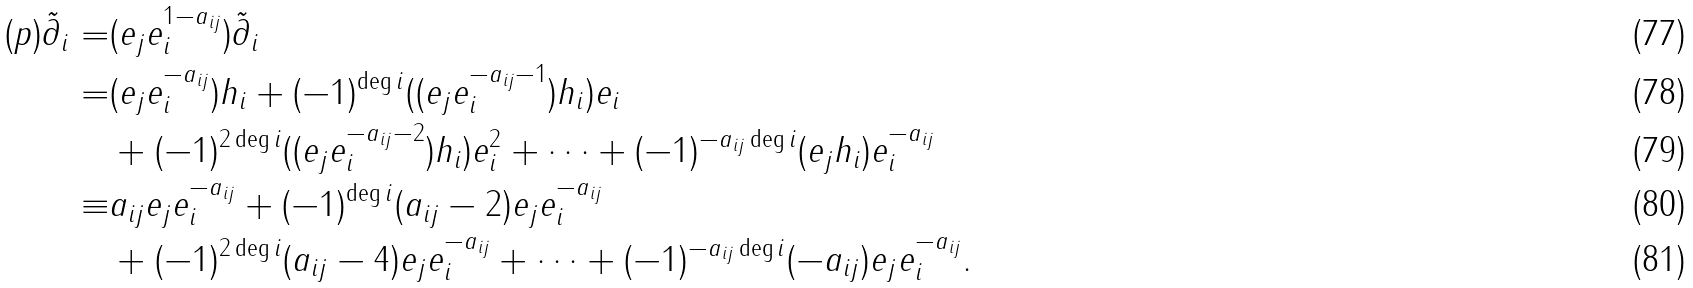<formula> <loc_0><loc_0><loc_500><loc_500>( p ) \tilde { \partial } _ { i } = & ( e _ { j } e _ { i } ^ { 1 - a _ { i j } } ) \tilde { \partial } _ { i } \\ = & ( e _ { j } e _ { i } ^ { - a _ { i j } } ) h _ { i } + ( - 1 ) ^ { \deg i } ( ( e _ { j } e _ { i } ^ { - a _ { i j } - 1 } ) h _ { i } ) e _ { i } \\ & + ( - 1 ) ^ { 2 \deg i } ( ( e _ { j } e _ { i } ^ { - a _ { i j } - 2 } ) h _ { i } ) e _ { i } ^ { 2 } + \dots + ( - 1 ) ^ { - a _ { i j } \deg i } ( e _ { j } h _ { i } ) e _ { i } ^ { - a _ { i j } } \\ \equiv & a _ { i j } e _ { j } e _ { i } ^ { - a _ { i j } } + ( - 1 ) ^ { \deg i } ( a _ { i j } - 2 ) e _ { j } e _ { i } ^ { - a _ { i j } } \\ & + ( - 1 ) ^ { 2 \deg i } ( a _ { i j } - 4 ) e _ { j } e _ { i } ^ { - a _ { i j } } + \dots + ( - 1 ) ^ { - a _ { i j } \deg i } ( - a _ { i j } ) e _ { j } e _ { i } ^ { - a _ { i j } } .</formula> 